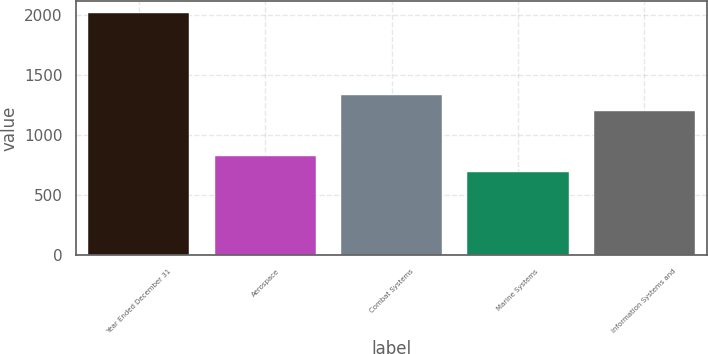Convert chart. <chart><loc_0><loc_0><loc_500><loc_500><bar_chart><fcel>Year Ended December 31<fcel>Aerospace<fcel>Combat Systems<fcel>Marine Systems<fcel>Information Systems and<nl><fcel>2011<fcel>823<fcel>1332<fcel>691<fcel>1200<nl></chart> 